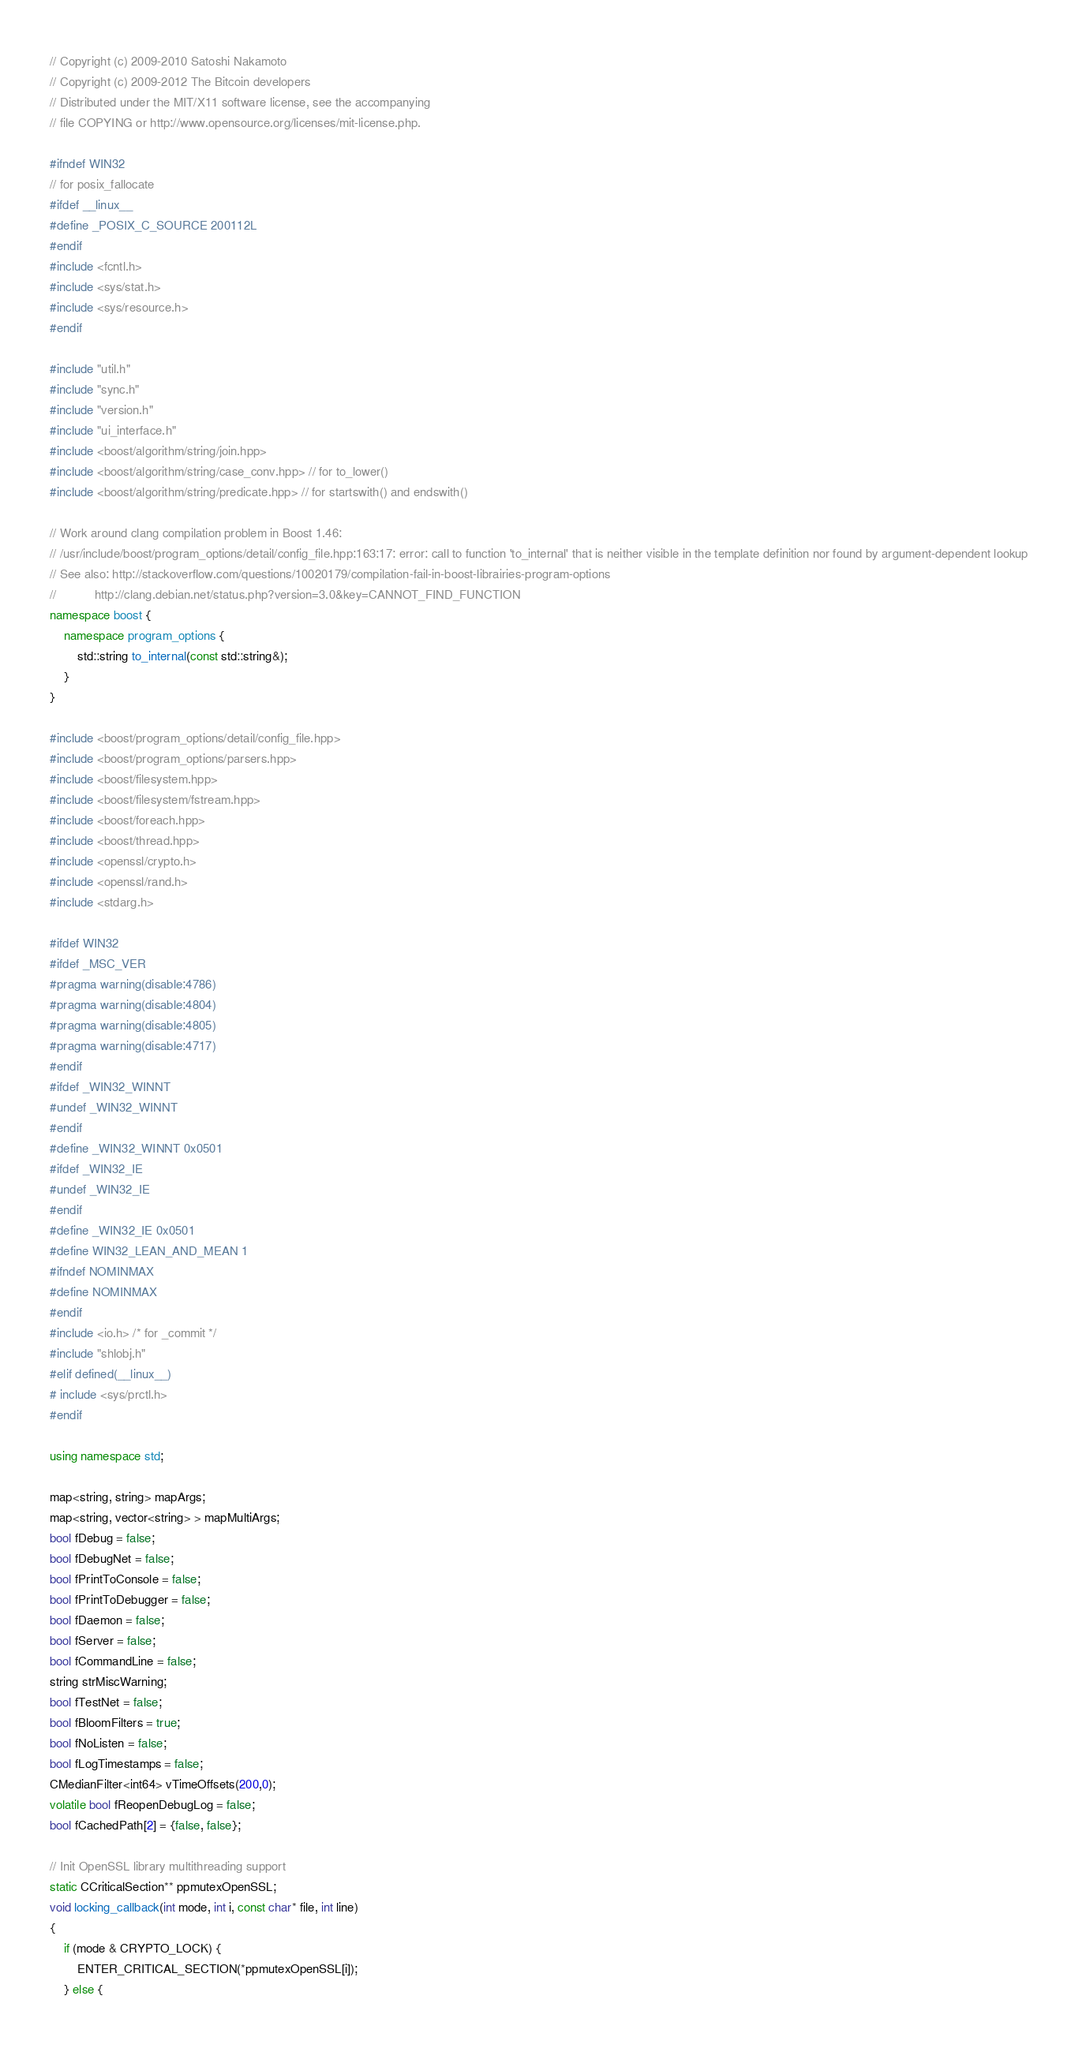Convert code to text. <code><loc_0><loc_0><loc_500><loc_500><_C++_>// Copyright (c) 2009-2010 Satoshi Nakamoto
// Copyright (c) 2009-2012 The Bitcoin developers
// Distributed under the MIT/X11 software license, see the accompanying
// file COPYING or http://www.opensource.org/licenses/mit-license.php.

#ifndef WIN32
// for posix_fallocate
#ifdef __linux__
#define _POSIX_C_SOURCE 200112L
#endif
#include <fcntl.h>
#include <sys/stat.h>
#include <sys/resource.h>
#endif

#include "util.h"
#include "sync.h"
#include "version.h"
#include "ui_interface.h"
#include <boost/algorithm/string/join.hpp>
#include <boost/algorithm/string/case_conv.hpp> // for to_lower()
#include <boost/algorithm/string/predicate.hpp> // for startswith() and endswith()

// Work around clang compilation problem in Boost 1.46:
// /usr/include/boost/program_options/detail/config_file.hpp:163:17: error: call to function 'to_internal' that is neither visible in the template definition nor found by argument-dependent lookup
// See also: http://stackoverflow.com/questions/10020179/compilation-fail-in-boost-librairies-program-options
//           http://clang.debian.net/status.php?version=3.0&key=CANNOT_FIND_FUNCTION
namespace boost {
    namespace program_options {
        std::string to_internal(const std::string&);
    }
}

#include <boost/program_options/detail/config_file.hpp>
#include <boost/program_options/parsers.hpp>
#include <boost/filesystem.hpp>
#include <boost/filesystem/fstream.hpp>
#include <boost/foreach.hpp>
#include <boost/thread.hpp>
#include <openssl/crypto.h>
#include <openssl/rand.h>
#include <stdarg.h>

#ifdef WIN32
#ifdef _MSC_VER
#pragma warning(disable:4786)
#pragma warning(disable:4804)
#pragma warning(disable:4805)
#pragma warning(disable:4717)
#endif
#ifdef _WIN32_WINNT
#undef _WIN32_WINNT
#endif
#define _WIN32_WINNT 0x0501
#ifdef _WIN32_IE
#undef _WIN32_IE
#endif
#define _WIN32_IE 0x0501
#define WIN32_LEAN_AND_MEAN 1
#ifndef NOMINMAX
#define NOMINMAX
#endif
#include <io.h> /* for _commit */
#include "shlobj.h"
#elif defined(__linux__)
# include <sys/prctl.h>
#endif

using namespace std;

map<string, string> mapArgs;
map<string, vector<string> > mapMultiArgs;
bool fDebug = false;
bool fDebugNet = false;
bool fPrintToConsole = false;
bool fPrintToDebugger = false;
bool fDaemon = false;
bool fServer = false;
bool fCommandLine = false;
string strMiscWarning;
bool fTestNet = false;
bool fBloomFilters = true;
bool fNoListen = false;
bool fLogTimestamps = false;
CMedianFilter<int64> vTimeOffsets(200,0);
volatile bool fReopenDebugLog = false;
bool fCachedPath[2] = {false, false};

// Init OpenSSL library multithreading support
static CCriticalSection** ppmutexOpenSSL;
void locking_callback(int mode, int i, const char* file, int line)
{
    if (mode & CRYPTO_LOCK) {
        ENTER_CRITICAL_SECTION(*ppmutexOpenSSL[i]);
    } else {</code> 